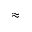Convert formula to latex. <formula><loc_0><loc_0><loc_500><loc_500>\approx</formula> 